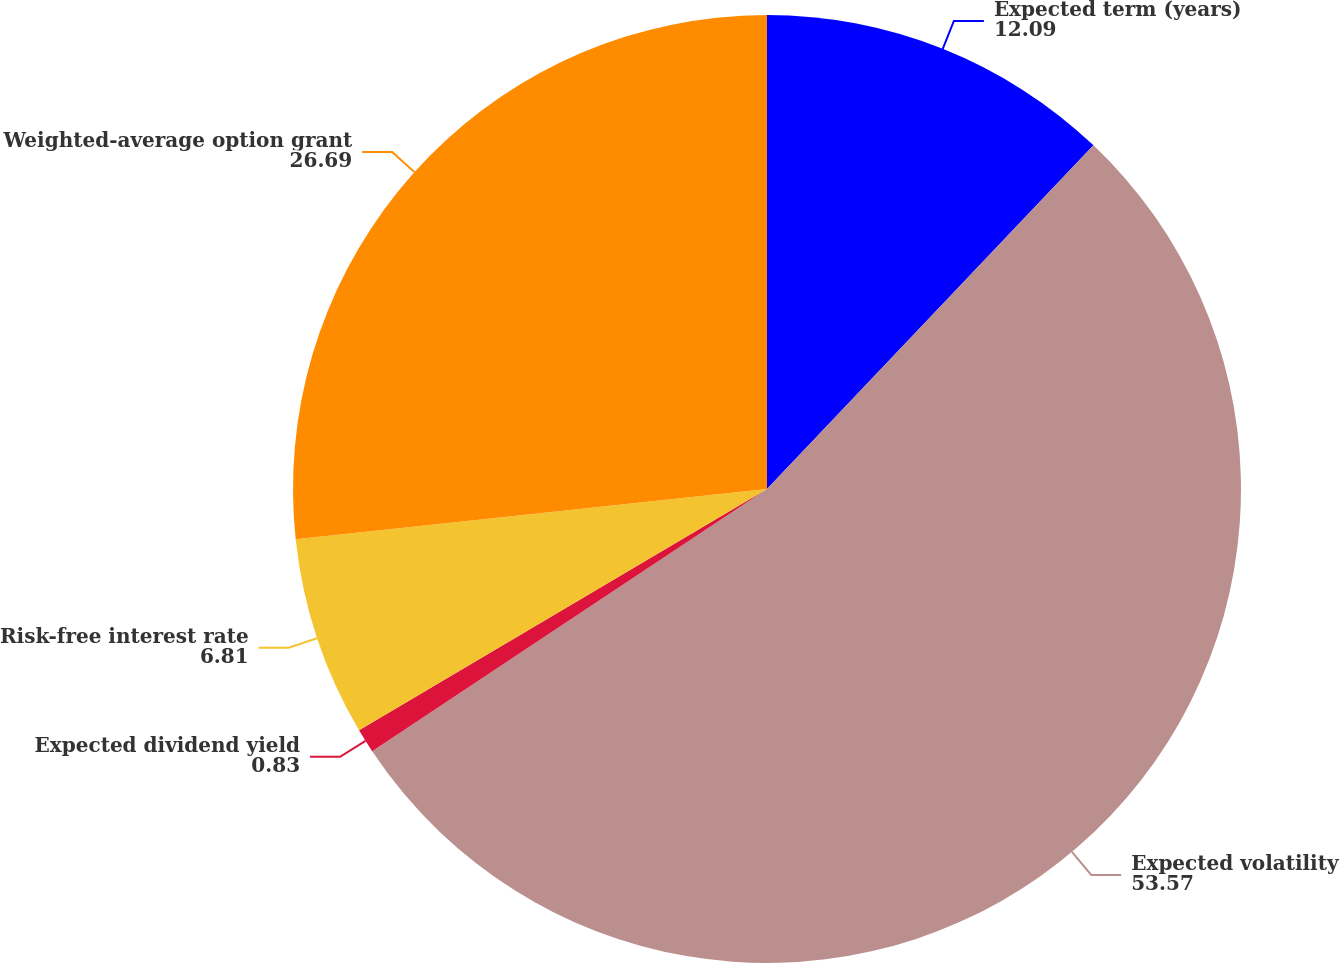<chart> <loc_0><loc_0><loc_500><loc_500><pie_chart><fcel>Expected term (years)<fcel>Expected volatility<fcel>Expected dividend yield<fcel>Risk-free interest rate<fcel>Weighted-average option grant<nl><fcel>12.09%<fcel>53.57%<fcel>0.83%<fcel>6.81%<fcel>26.69%<nl></chart> 